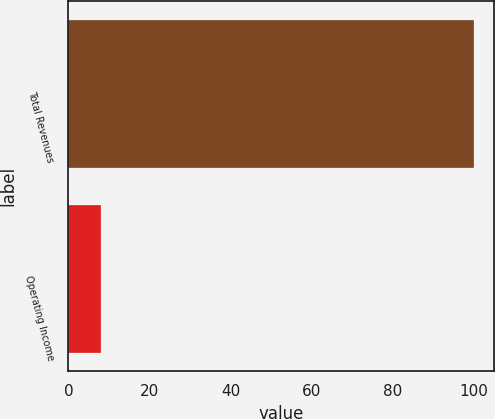Convert chart. <chart><loc_0><loc_0><loc_500><loc_500><bar_chart><fcel>Total Revenues<fcel>Operating Income<nl><fcel>100<fcel>8<nl></chart> 